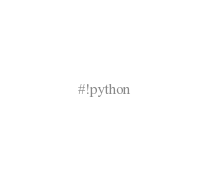<code> <loc_0><loc_0><loc_500><loc_500><_Cython_>#!python</code> 